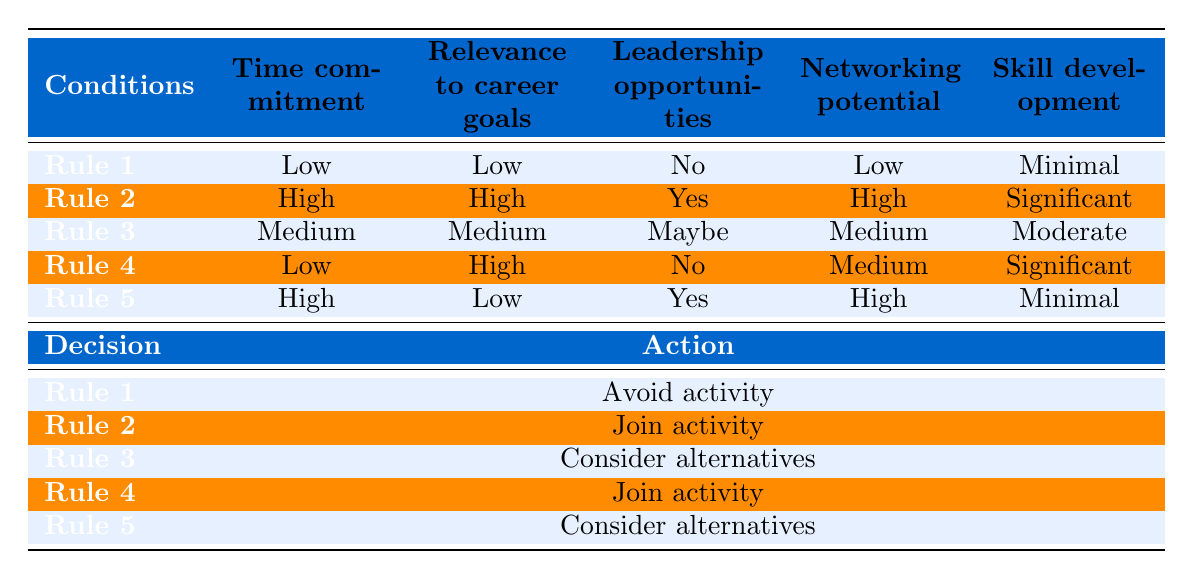What is the decision for an activity with high time commitment, high relevance to career goals, leadership opportunities, high networking potential, and significant skill development? According to Rule 2 in the table, when the conditions are high for time commitment, relevance to career goals, and networking potential, and there are leadership opportunities along with significant skill development, the decision is to "Join activity."
Answer: Join activity How many activities recommend to "Consider alternatives"? By reviewing the rules, Rule 3 and Rule 5 both suggest to "Consider alternatives." Therefore, there are 2 activities with this recommendation.
Answer: 2 Does volunteering at a local food bank provide significant skill development? Looking at the rule corresponding to volunteering at a local food bank, it indicates "Minimal" skill development. Therefore, the answer is no, it does not provide significant skill development.
Answer: No Which activity has low time commitment and high relevance to career goals? Rule 4 describes an activity with low time commitment and high relevance to career goals, which corresponds to joining an activity. The specific activity is not named in the rule set, but it clearly indicates a decision to join.
Answer: Join activity What is the average level of skill development among activities suggesting to join? The activities that suggest to join are from Rule 2 and Rule 4. Both suggest significant skill development. To find the average: (Significant + Significant) / 2 = 2 / 2 = 1 (if significant is indicated as 2). Therefore, the average skill development level is significant.
Answer: Significant 